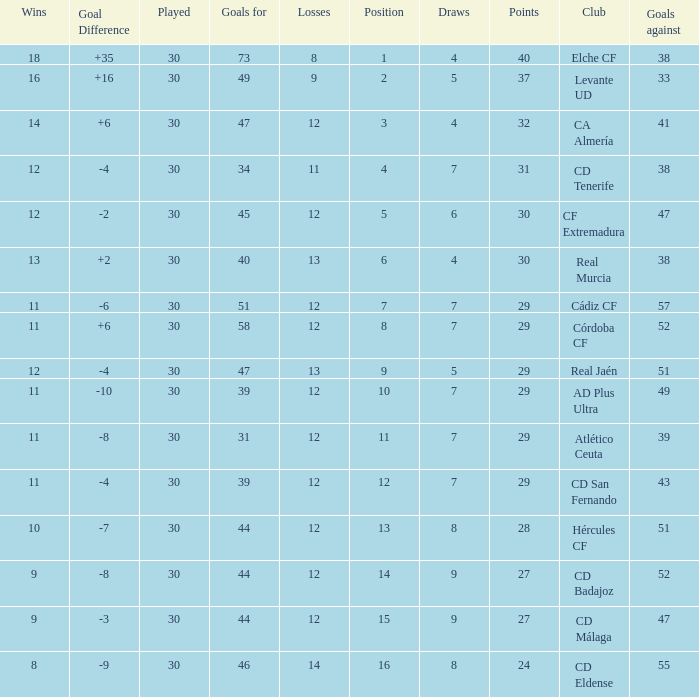What is the average number of goals against with more than 12 wins, 12 losses, and a position greater than 3? None. 